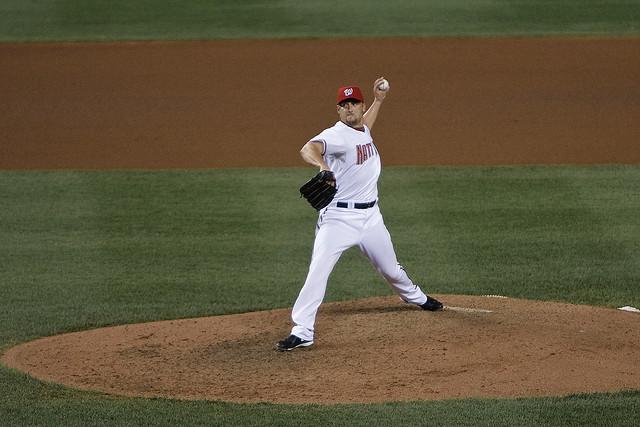Who is batting?
Answer briefly. Batter. What game is this?
Quick response, please. Baseball. Has the ball been thrown yet?
Be succinct. No. What position is the guy playing?
Answer briefly. Pitcher. What hand is wearing the glove?
Short answer required. Right. Where is the ball?
Answer briefly. In hand. What color is the man's hat?
Be succinct. Red. What is the guy about to throw?
Keep it brief. Baseball. How many players are in this photo?
Answer briefly. 1. Which man has the baseball?
Quick response, please. Pitcher. What team just scored a run?
Concise answer only. Nationals. What color is the pitcher's hat?
Quick response, please. Red. 